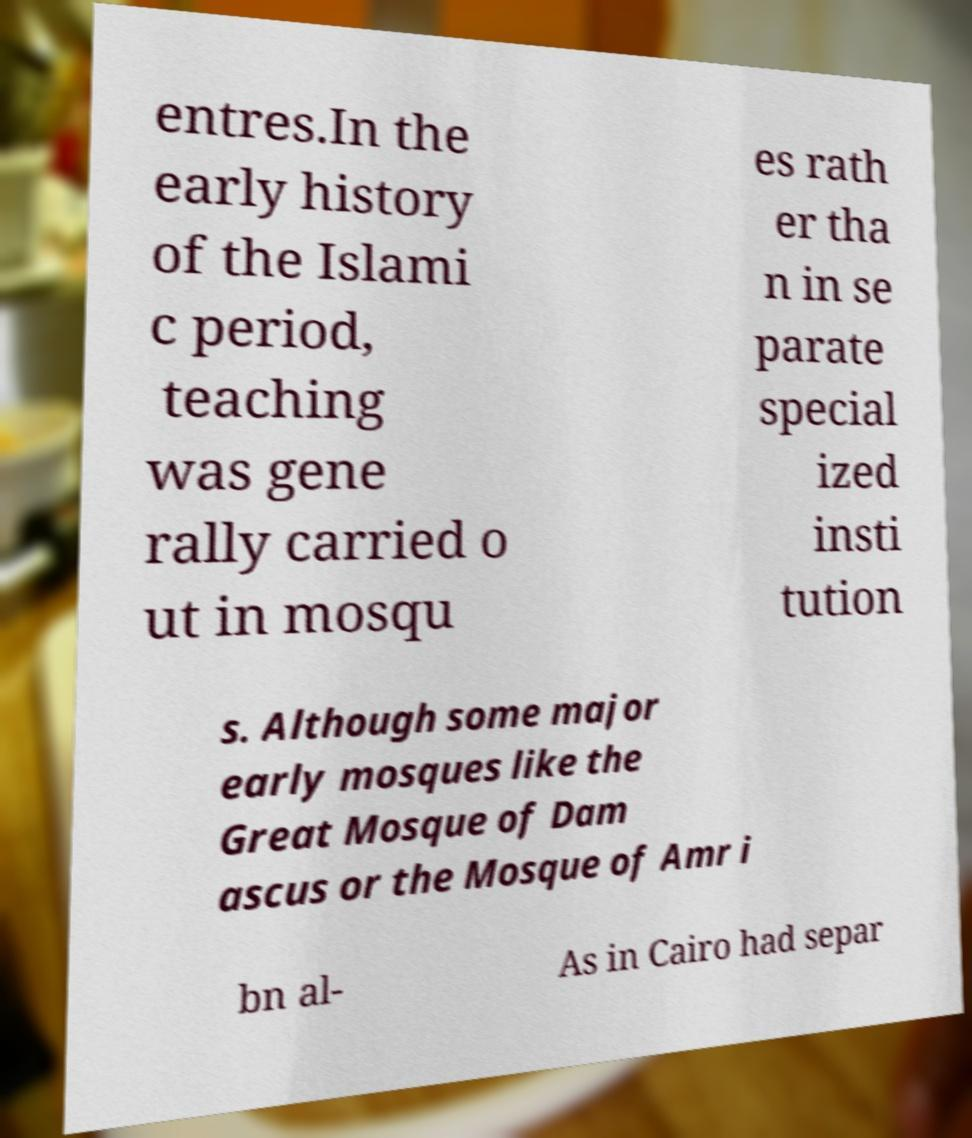Can you accurately transcribe the text from the provided image for me? entres.In the early history of the Islami c period, teaching was gene rally carried o ut in mosqu es rath er tha n in se parate special ized insti tution s. Although some major early mosques like the Great Mosque of Dam ascus or the Mosque of Amr i bn al- As in Cairo had separ 